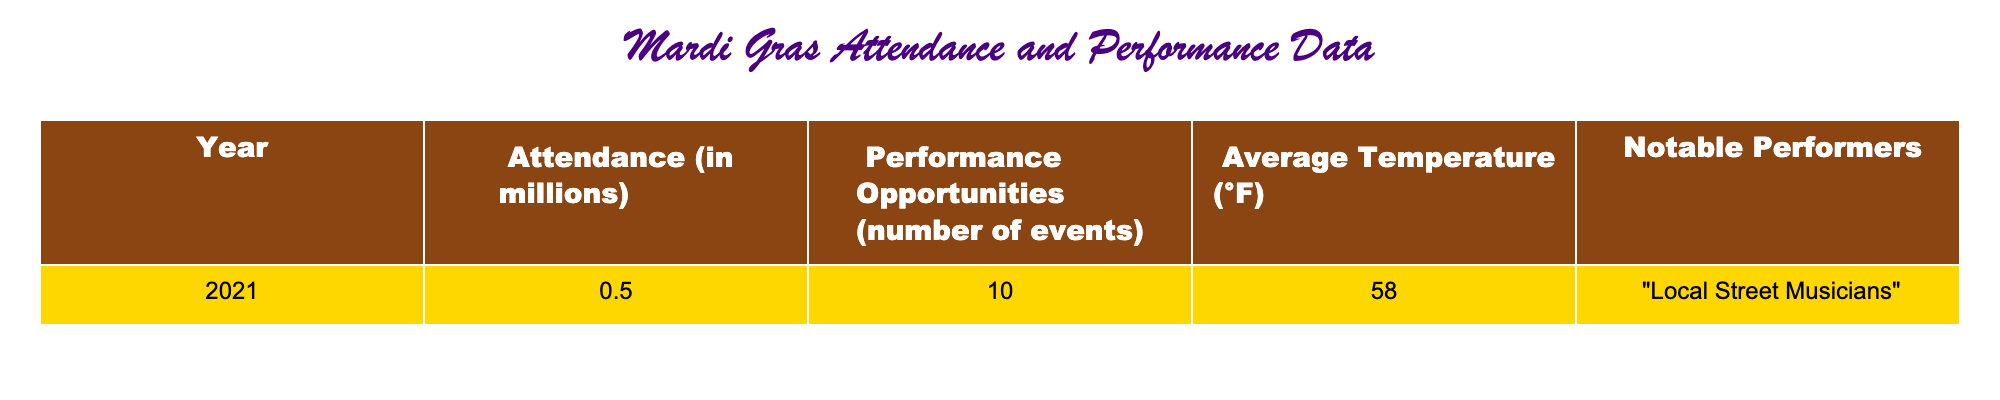What was the attendance in millions for Mardi Gras in 2021? The table indicates that the attendance for Mardi Gras in the year 2021 was documented as 0.5 million.
Answer: 0.5 million How many performance opportunities were there in 2021? Referring to the table, it shows that there were 10 performance opportunities listed for Mardi Gras in 2021.
Answer: 10 Was the average temperature during Mardi Gras in 2021 above or below 60°F? The table presents the average temperature for Mardi Gras in 2021 as 58°F, which is below 60°F.
Answer: Below Who were the notable performers in 2021? According to the table, the notable performers for Mardi Gras in 2021 were "Local Street Musicians."
Answer: Local Street Musicians How much did Mardi Gras attendance decrease from a typical year (assuming attendance is generally higher)? This question requires an assumption since the table does not show typical attendance; however, if we consider that attendance in years before might be higher (assuming average attendance typically exceeds 0.5 million), then we could conclude there was a decrease. Hence, the overall impact suggests a significant reduction in attendance in 2021.
Answer: Significant reduction What was the percentage increase in performance opportunities if there were 15 events in a typical year? To find the percentage change from a typical year of 15 events to 10 events, we can calculate (10 - 15) / 15 * 100. This equals -33.33%, indicating a decrease of approximately 33.33% in performance opportunities.
Answer: -33.33% Did the attendance correlate positively with the number of performance opportunities in 2021? To assess correlation, we look at the attendance of 0.5 million and performance opportunities of 10. While a larger data set would give more insights, with only one year available and a limited attendance to opportunities ratio, we can't definitively say there is a positive correlation, but it seems low parameters do exist. Thus, we can't confidently claim a positive correlation.
Answer: No How does the average temperature relate to attendance? The average temperature for Mardi Gras in 2021 was 58°F. While the table doesn't directly relate temperature to attendance, if we consider general trends where warmer temperatures might encourage more attendees, we cannot derive a relationship without broader data. Therefore, based on this single data point, we cannot make a definite connection.
Answer: Insufficient data 